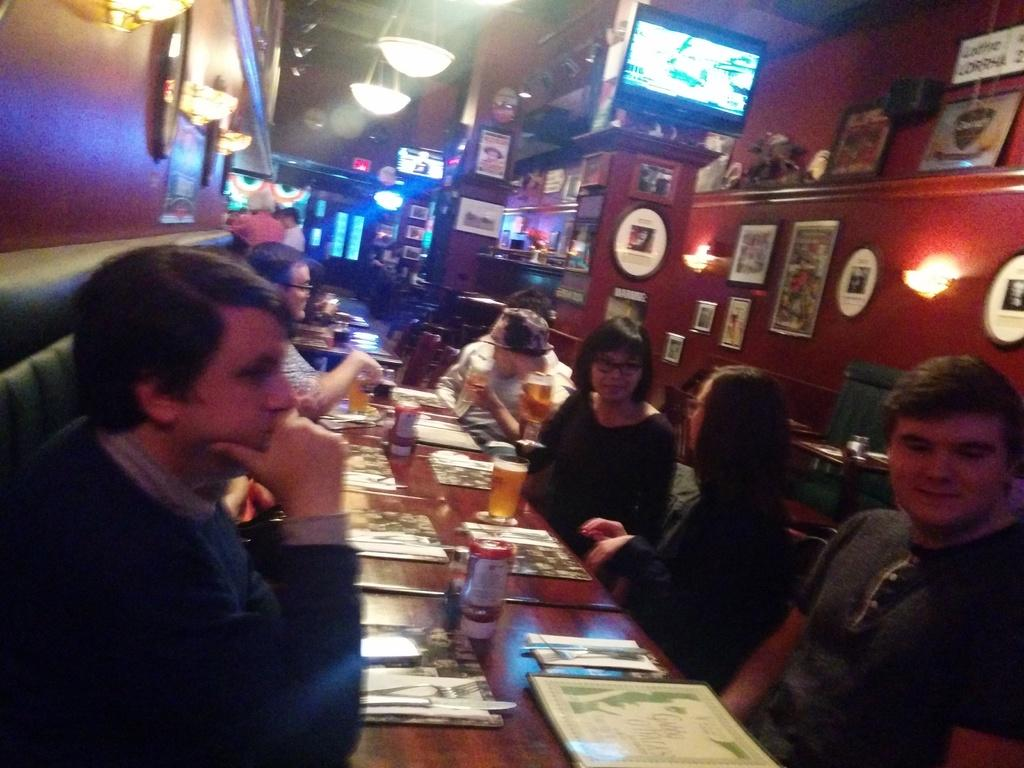What are the people in the image doing? The people in the image are sitting on chairs. What is present on the table in the image? There are wine glasses on the table. Can you describe the setting in the image? The setting includes people sitting on chairs and a table with wine glasses. What type of representative is sitting on the bike in the image? There is no representative or bike present in the image. What book is the person reading in the image? There is no book or reading activity depicted in the image. 